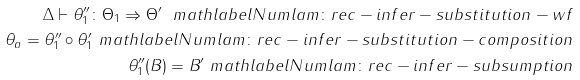Convert formula to latex. <formula><loc_0><loc_0><loc_500><loc_500>\Delta \vdash \theta ^ { \prime \prime } _ { 1 } \colon \Theta _ { 1 } \Rightarrow \Theta ^ { \prime } \ m a t h l a b e l N u m { l a m \colon r e c - i n f e r - s u b s t i t u t i o n - w f } \\ \theta _ { a } = \theta ^ { \prime \prime } _ { 1 } \circ \theta ^ { \prime } _ { 1 } \ m a t h l a b e l N u m { l a m \colon r e c - i n f e r - s u b s t i t u t i o n - c o m p o s i t i o n } \\ \theta ^ { \prime \prime } _ { 1 } ( B ) = B ^ { \prime } \ m a t h l a b e l N u m { l a m \colon r e c - i n f e r - s u b s u m p t i o n }</formula> 